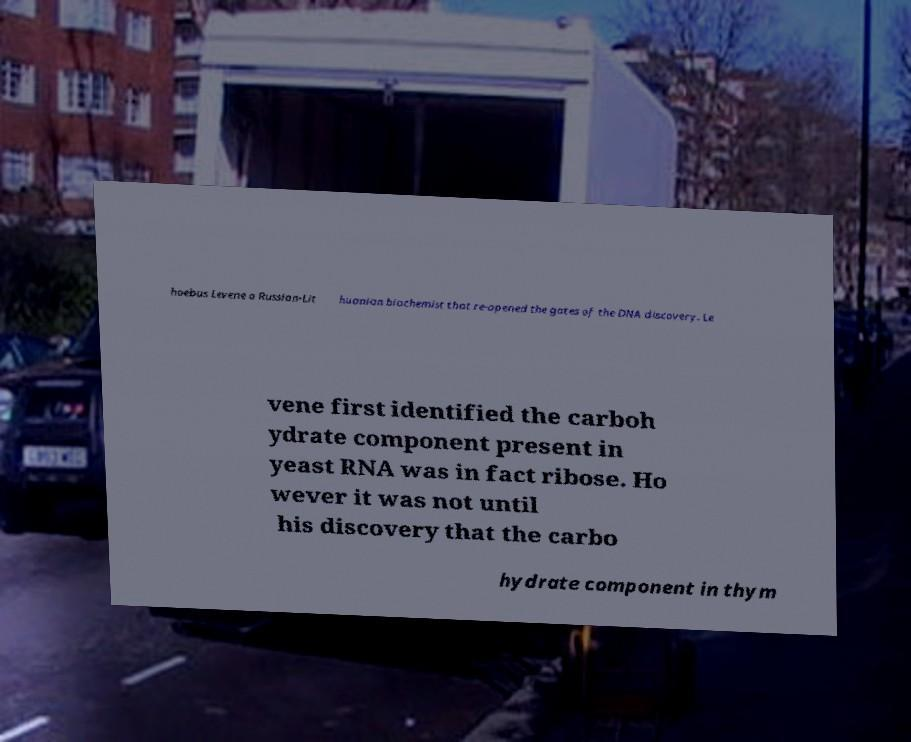I need the written content from this picture converted into text. Can you do that? hoebus Levene a Russian-Lit huanian biochemist that re-opened the gates of the DNA discovery. Le vene first identified the carboh ydrate component present in yeast RNA was in fact ribose. Ho wever it was not until his discovery that the carbo hydrate component in thym 